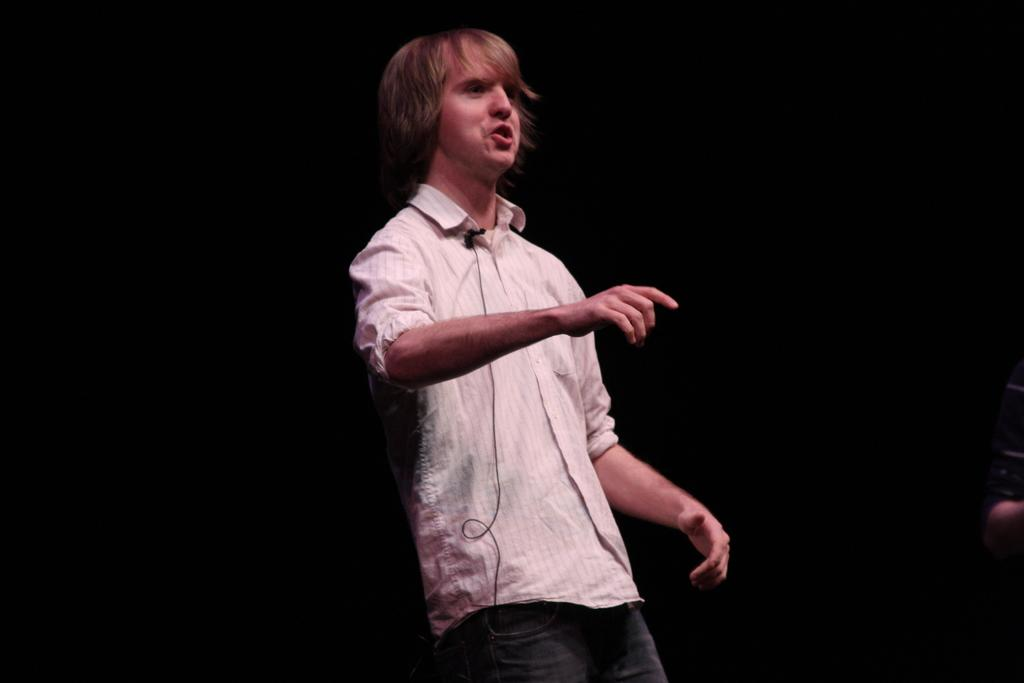What is the person in the image doing? The person is standing and talking. What object is the person holding or using while talking? The person has a mic with a wire attached to their shirt. What can be observed about the lighting or color of the background in the image? The background of the image is dark. How many sheep can be seen in the image? There are no sheep present in the image. What type of kitty is sitting on the person's shoe in the image? There is no kitty or shoe visible in the image. 